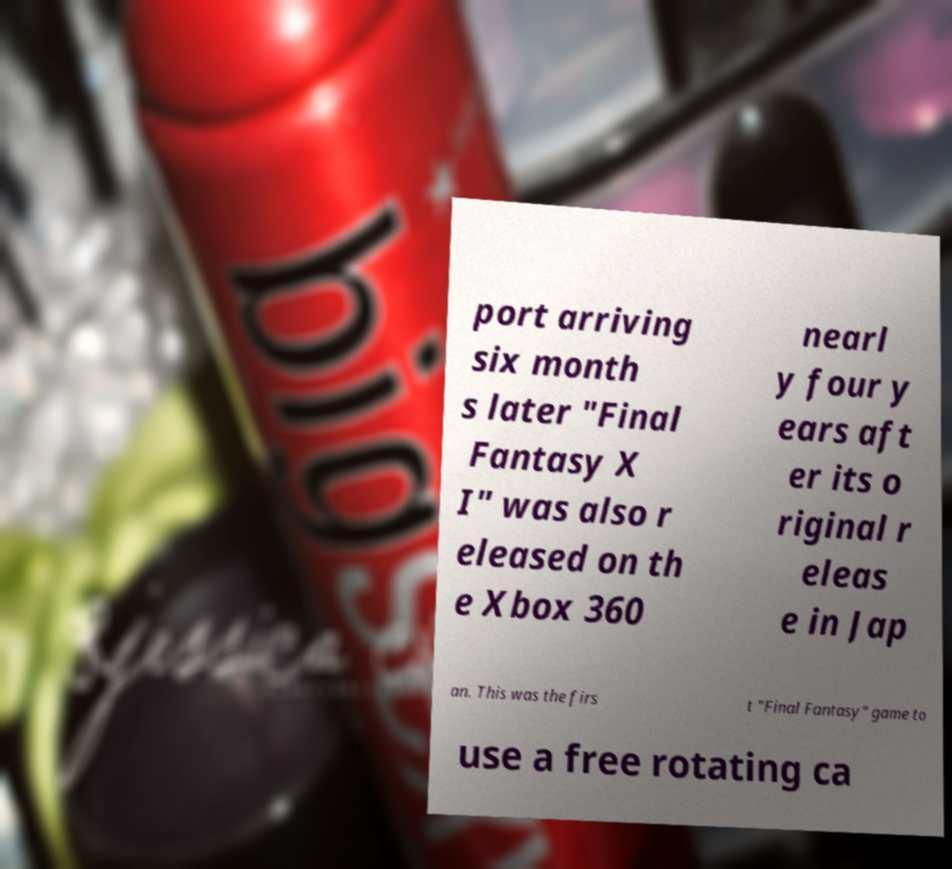I need the written content from this picture converted into text. Can you do that? port arriving six month s later "Final Fantasy X I" was also r eleased on th e Xbox 360 nearl y four y ears aft er its o riginal r eleas e in Jap an. This was the firs t "Final Fantasy" game to use a free rotating ca 